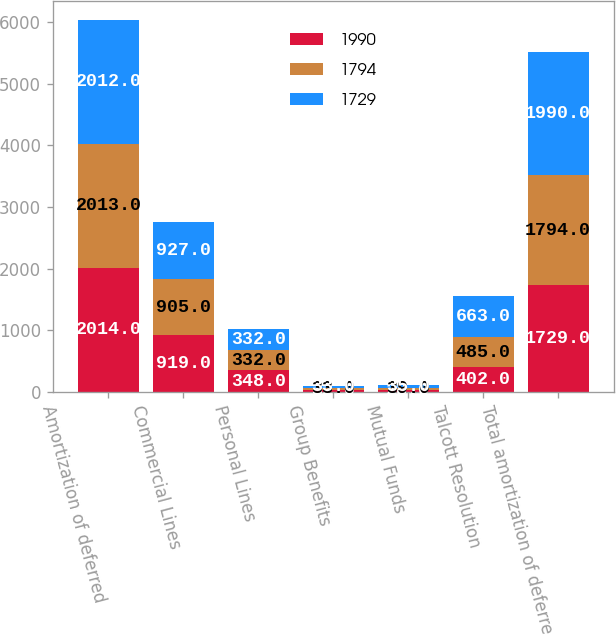<chart> <loc_0><loc_0><loc_500><loc_500><stacked_bar_chart><ecel><fcel>Amortization of deferred<fcel>Commercial Lines<fcel>Personal Lines<fcel>Group Benefits<fcel>Mutual Funds<fcel>Talcott Resolution<fcel>Total amortization of deferred<nl><fcel>1990<fcel>2014<fcel>919<fcel>348<fcel>32<fcel>28<fcel>402<fcel>1729<nl><fcel>1794<fcel>2013<fcel>905<fcel>332<fcel>33<fcel>39<fcel>485<fcel>1794<nl><fcel>1729<fcel>2012<fcel>927<fcel>332<fcel>33<fcel>35<fcel>663<fcel>1990<nl></chart> 